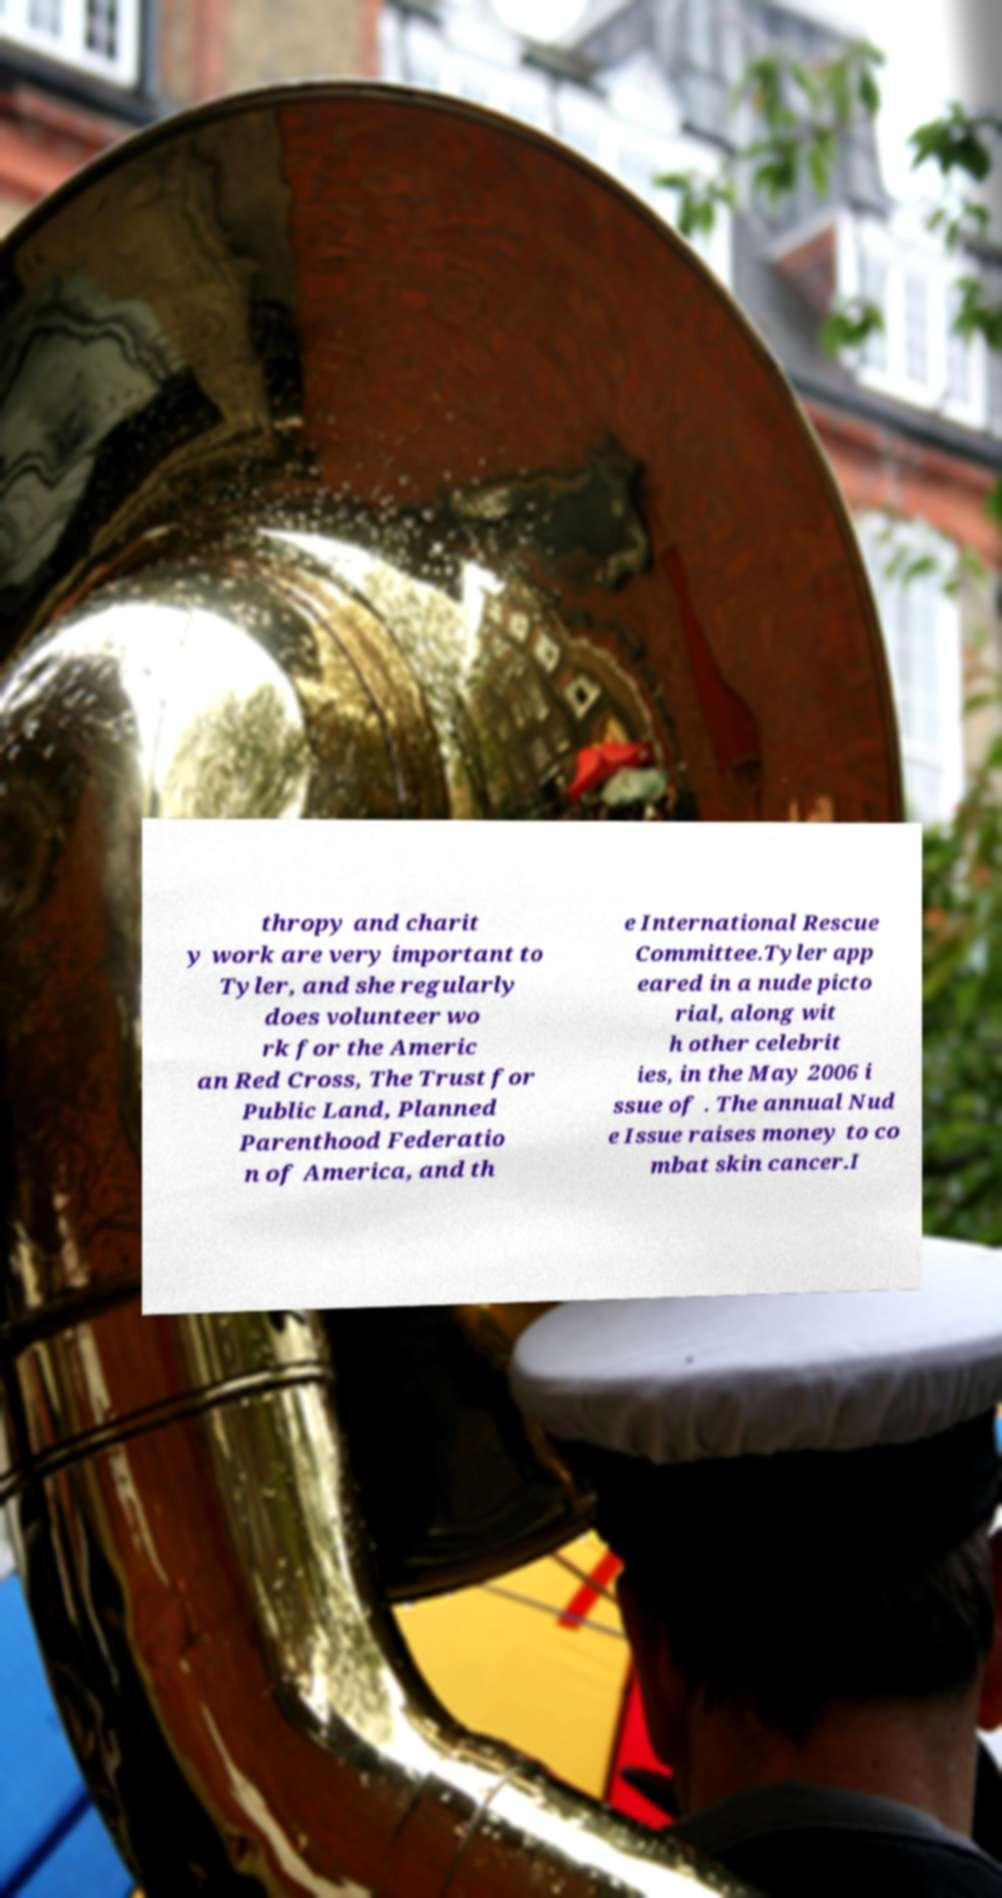Can you accurately transcribe the text from the provided image for me? thropy and charit y work are very important to Tyler, and she regularly does volunteer wo rk for the Americ an Red Cross, The Trust for Public Land, Planned Parenthood Federatio n of America, and th e International Rescue Committee.Tyler app eared in a nude picto rial, along wit h other celebrit ies, in the May 2006 i ssue of . The annual Nud e Issue raises money to co mbat skin cancer.I 